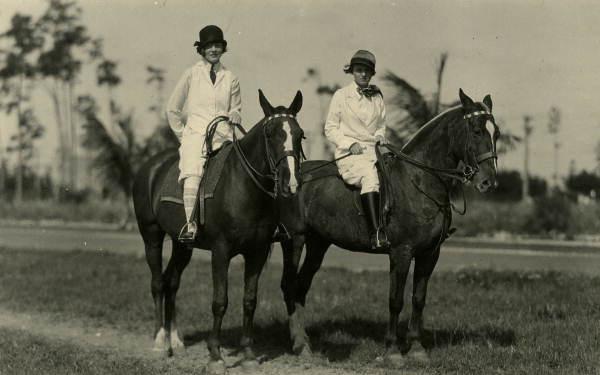Are any of the animals in the photos babies?
Give a very brief answer. No. Does the photo look like a Polo advertisement?
Answer briefly. Yes. What are the horses standing on?
Short answer required. Grass. Are these men or women?
Concise answer only. Women. How many horses are seen in the image?
Write a very short answer. 2. Is it spotted?
Concise answer only. No. How many animals can be seen?
Concise answer only. 2. Are they walking on a sidewalk?
Write a very short answer. No. Who are riding the horses?
Be succinct. Women. Is this animal male?
Short answer required. No. What are horses doing?
Quick response, please. Standing. Are any riders standing?
Answer briefly. No. How many  horses are standing next to each other?
Give a very brief answer. 2. What's behind the horses?
Write a very short answer. Trees. What are the riders wearing on their heads?
Write a very short answer. Hats. How many men are wearing hats?
Be succinct. 2. Are the horses moving forward?
Answer briefly. No. Are the two horses the same color?
Quick response, please. Yes. What are on the peoples heads?
Quick response, please. Hats. How many people can be seen?
Keep it brief. 2. What color is the grass?
Be succinct. Green. 